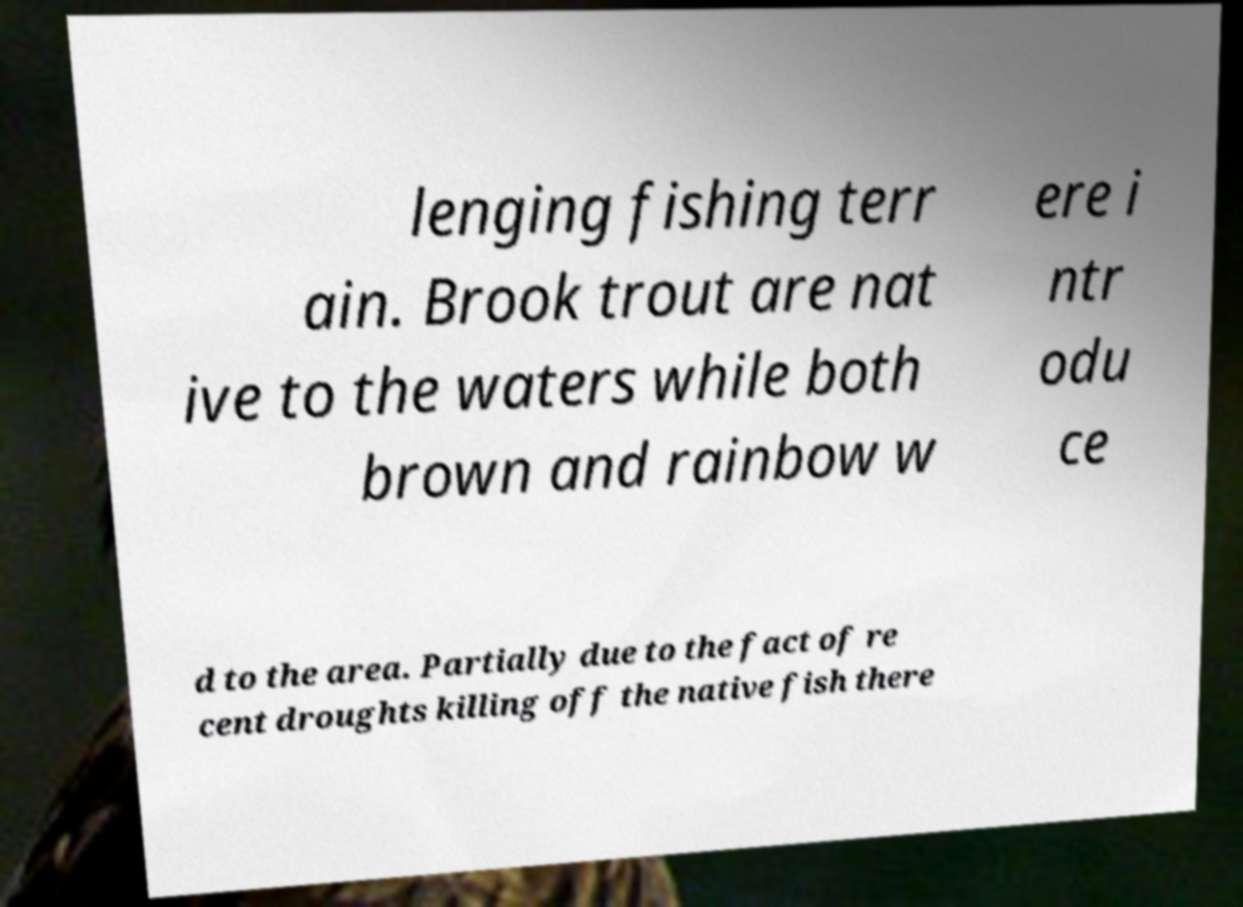What messages or text are displayed in this image? I need them in a readable, typed format. lenging fishing terr ain. Brook trout are nat ive to the waters while both brown and rainbow w ere i ntr odu ce d to the area. Partially due to the fact of re cent droughts killing off the native fish there 